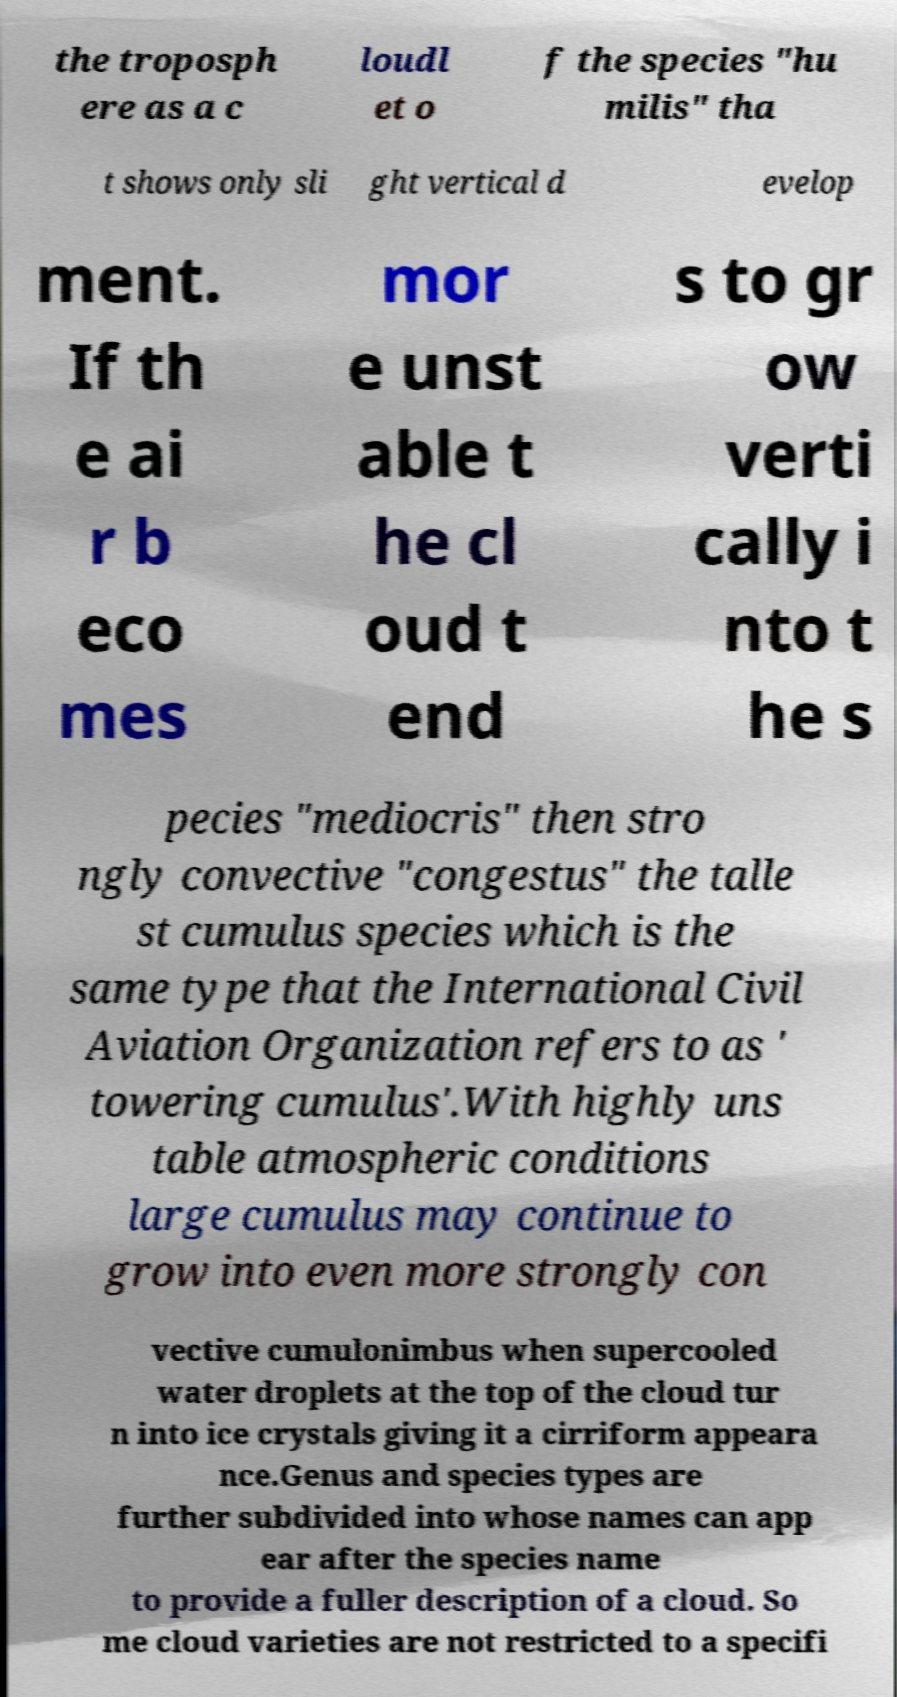Can you read and provide the text displayed in the image?This photo seems to have some interesting text. Can you extract and type it out for me? the troposph ere as a c loudl et o f the species "hu milis" tha t shows only sli ght vertical d evelop ment. If th e ai r b eco mes mor e unst able t he cl oud t end s to gr ow verti cally i nto t he s pecies "mediocris" then stro ngly convective "congestus" the talle st cumulus species which is the same type that the International Civil Aviation Organization refers to as ' towering cumulus'.With highly uns table atmospheric conditions large cumulus may continue to grow into even more strongly con vective cumulonimbus when supercooled water droplets at the top of the cloud tur n into ice crystals giving it a cirriform appeara nce.Genus and species types are further subdivided into whose names can app ear after the species name to provide a fuller description of a cloud. So me cloud varieties are not restricted to a specifi 